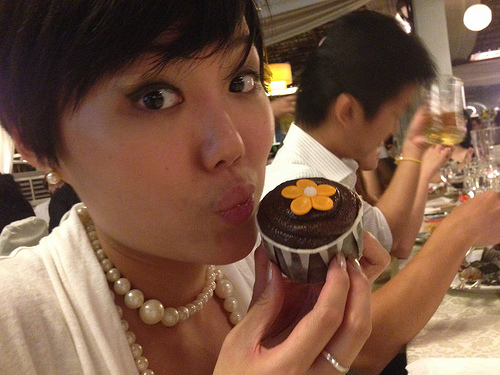Who is wearing the shirt? A man is wearing the shirt. 